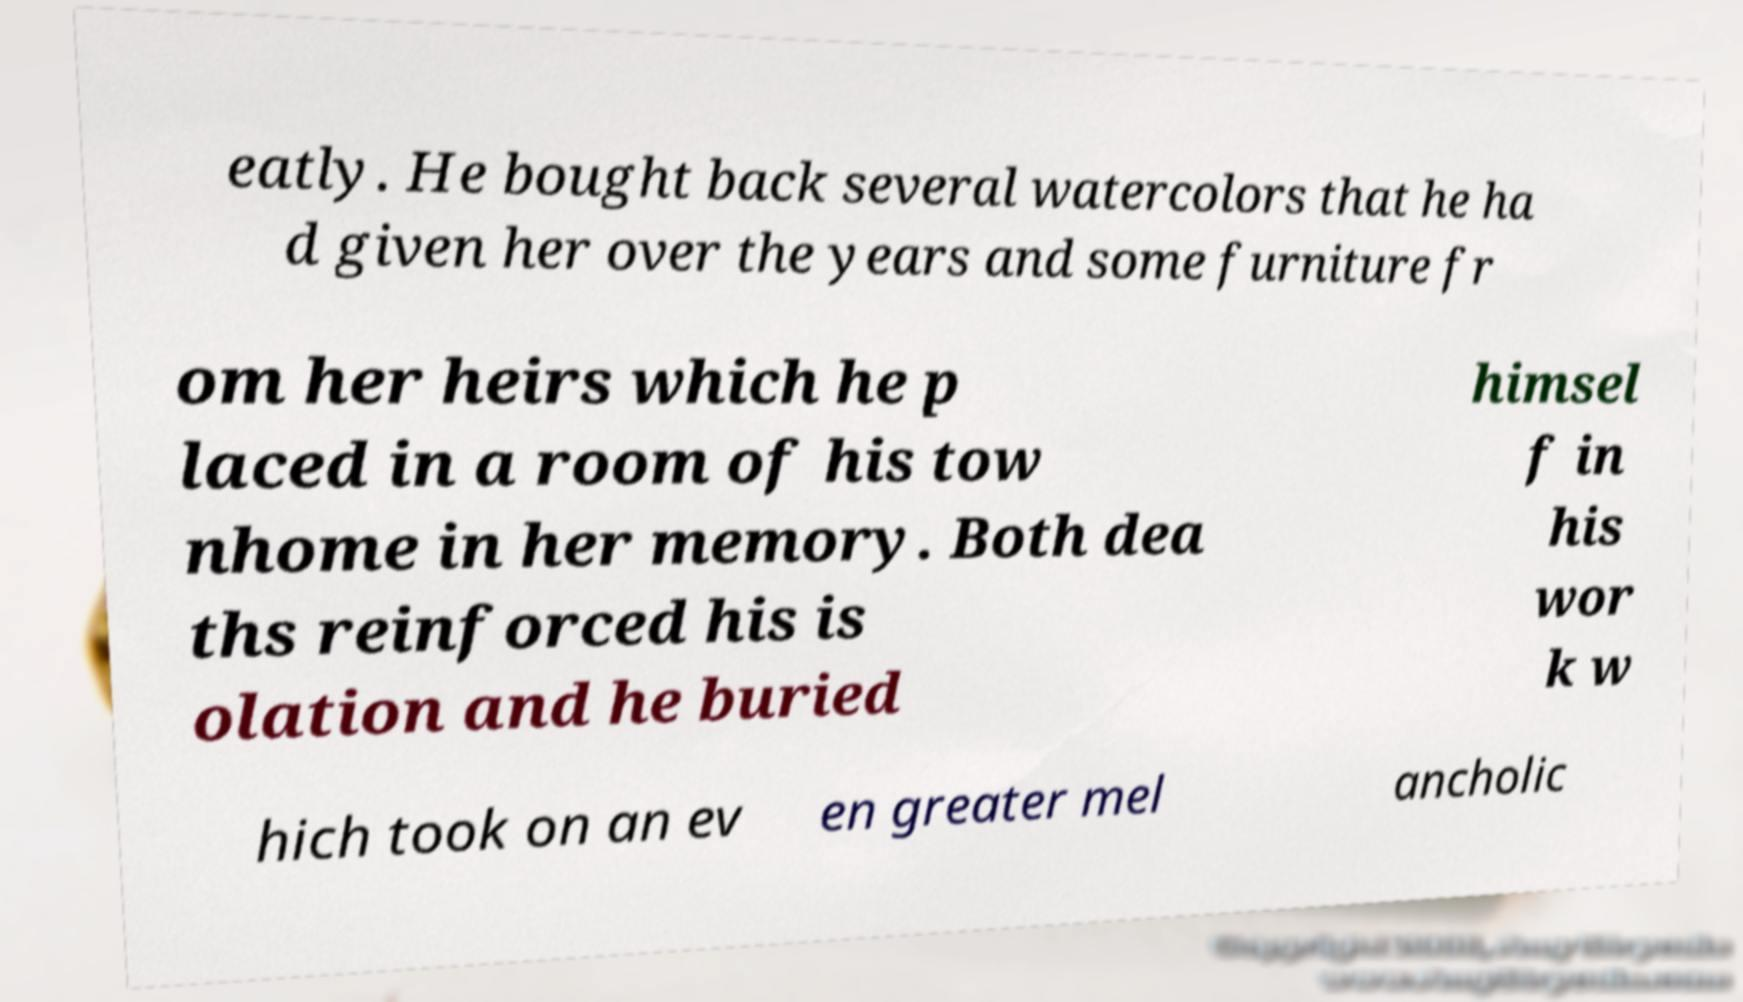Can you accurately transcribe the text from the provided image for me? eatly. He bought back several watercolors that he ha d given her over the years and some furniture fr om her heirs which he p laced in a room of his tow nhome in her memory. Both dea ths reinforced his is olation and he buried himsel f in his wor k w hich took on an ev en greater mel ancholic 